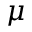<formula> <loc_0><loc_0><loc_500><loc_500>\mu</formula> 